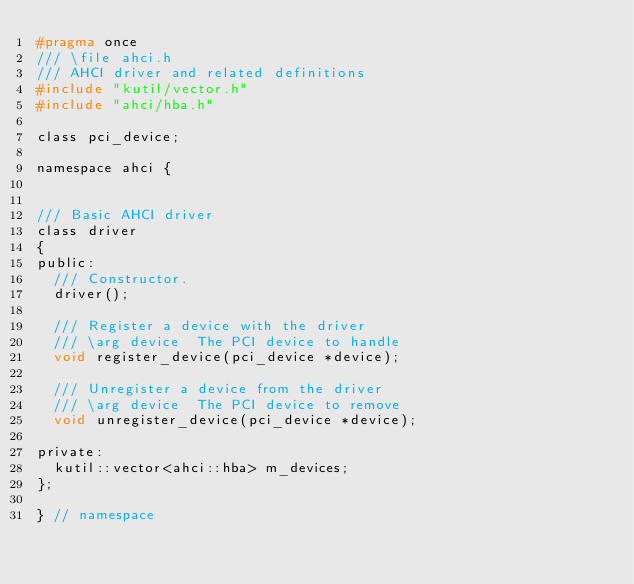<code> <loc_0><loc_0><loc_500><loc_500><_C_>#pragma once
/// \file ahci.h
/// AHCI driver and related definitions
#include "kutil/vector.h"
#include "ahci/hba.h"

class pci_device;

namespace ahci {


/// Basic AHCI driver
class driver
{
public:
	/// Constructor.
	driver();

	/// Register a device with the driver
	/// \arg device  The PCI device to handle
	void register_device(pci_device *device);

	/// Unregister a device from the driver
	/// \arg device  The PCI device to remove
	void unregister_device(pci_device *device);

private:
	kutil::vector<ahci::hba> m_devices;
};

} // namespace
</code> 